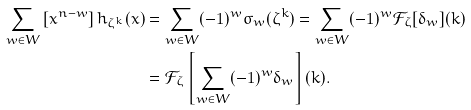<formula> <loc_0><loc_0><loc_500><loc_500>\sum _ { w \in W } \left [ x ^ { n - w } \right ] h _ { \zeta ^ { k } } ( x ) & = \sum _ { w \in W } ( - 1 ) ^ { w } \sigma _ { w } ( \zeta ^ { k } ) = \sum _ { w \in W } ( - 1 ) ^ { w } \mathcal { F } _ { \zeta } [ \delta _ { w } ] ( k ) \\ & = \mathcal { F } _ { \zeta } \left [ \sum _ { w \in W } ( - 1 ) ^ { w } \delta _ { w } \right ] ( k ) .</formula> 